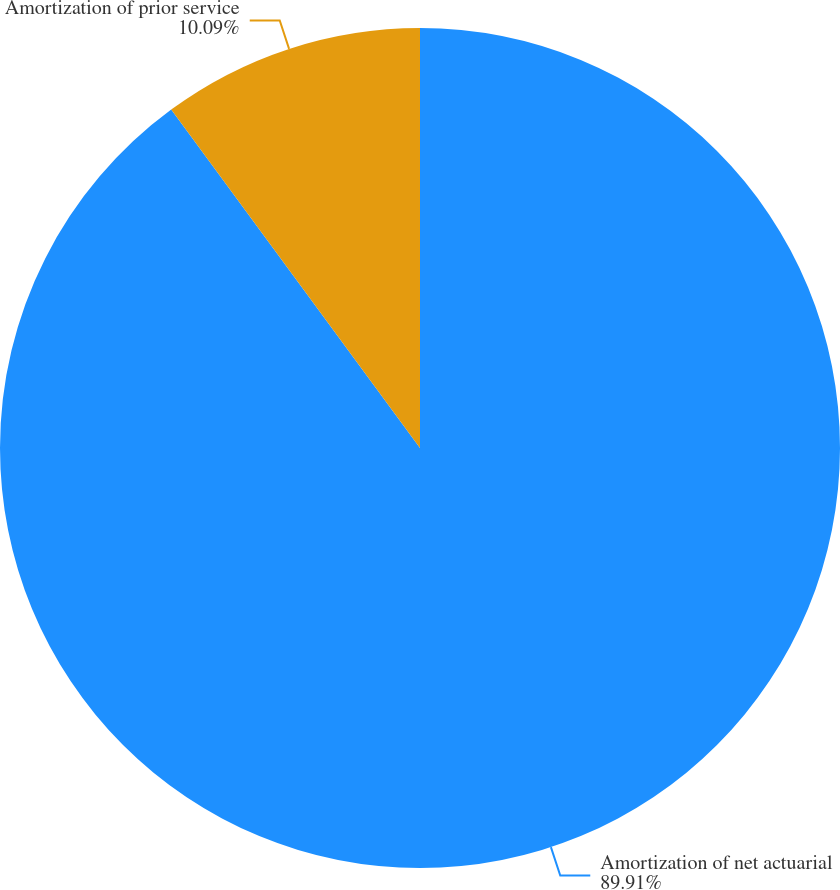<chart> <loc_0><loc_0><loc_500><loc_500><pie_chart><fcel>Amortization of net actuarial<fcel>Amortization of prior service<nl><fcel>89.91%<fcel>10.09%<nl></chart> 